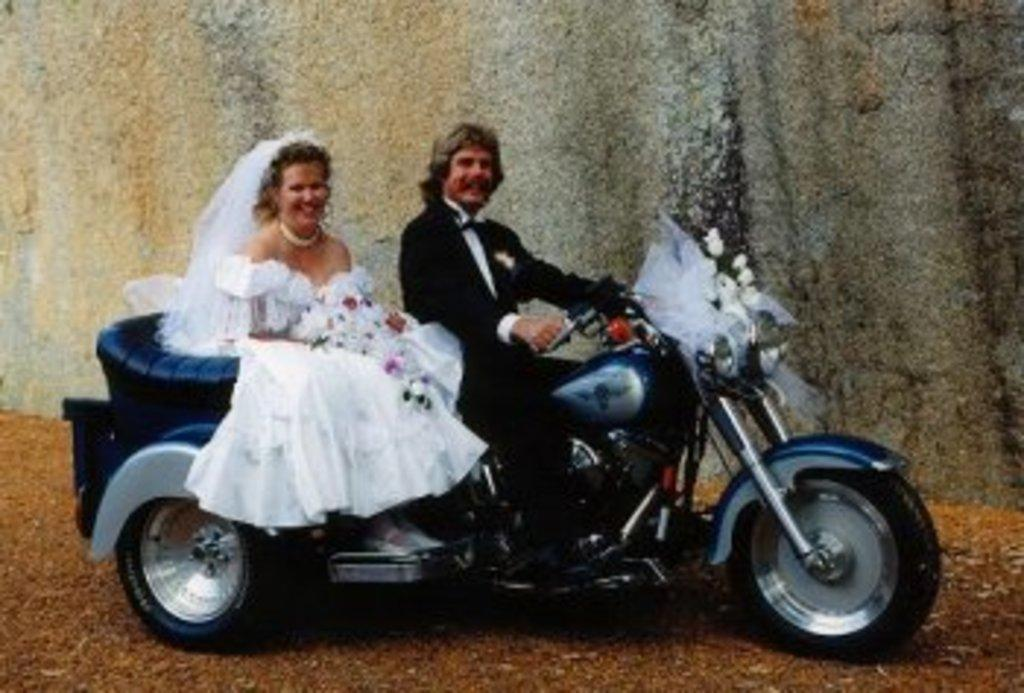What type of event is depicted in the image? The image features a newly married couple, suggesting it is a wedding or post-wedding event. What is the man wearing in the image? The man is wearing a black suit in the image. What is the woman wearing in the image? The woman is wearing a white gown with a veil in the image. What mode of transportation is the couple using in the image? The couple is sitting on a bike in the image. What type of fruit is the couple producing in the image? There is no fruit production depicted in the image; it features a newly married couple sitting on a bike. 